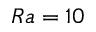Convert formula to latex. <formula><loc_0><loc_0><loc_500><loc_500>R a = 1 0</formula> 